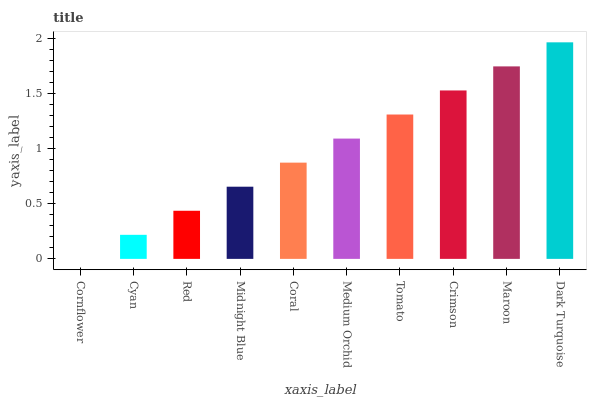Is Cornflower the minimum?
Answer yes or no. Yes. Is Dark Turquoise the maximum?
Answer yes or no. Yes. Is Cyan the minimum?
Answer yes or no. No. Is Cyan the maximum?
Answer yes or no. No. Is Cyan greater than Cornflower?
Answer yes or no. Yes. Is Cornflower less than Cyan?
Answer yes or no. Yes. Is Cornflower greater than Cyan?
Answer yes or no. No. Is Cyan less than Cornflower?
Answer yes or no. No. Is Medium Orchid the high median?
Answer yes or no. Yes. Is Coral the low median?
Answer yes or no. Yes. Is Red the high median?
Answer yes or no. No. Is Dark Turquoise the low median?
Answer yes or no. No. 